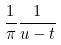Convert formula to latex. <formula><loc_0><loc_0><loc_500><loc_500>\frac { 1 } { \pi } \frac { 1 } { u - t }</formula> 